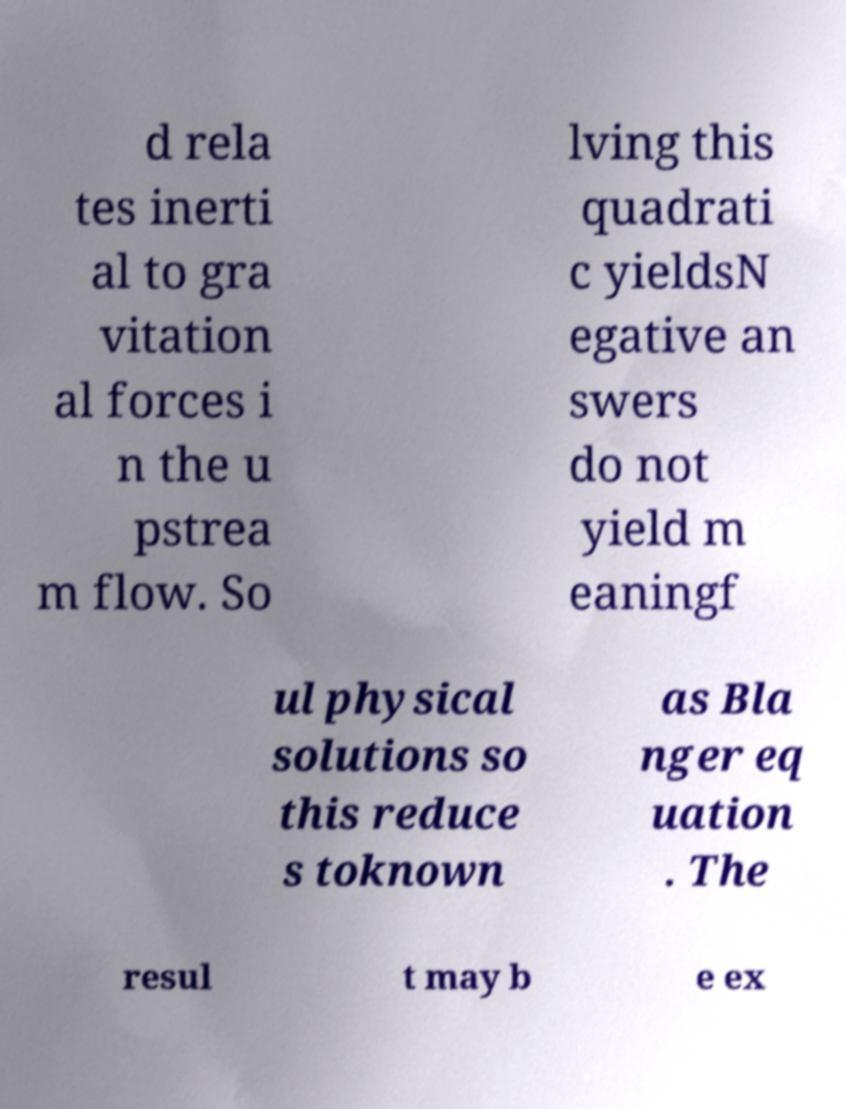There's text embedded in this image that I need extracted. Can you transcribe it verbatim? d rela tes inerti al to gra vitation al forces i n the u pstrea m flow. So lving this quadrati c yieldsN egative an swers do not yield m eaningf ul physical solutions so this reduce s toknown as Bla nger eq uation . The resul t may b e ex 